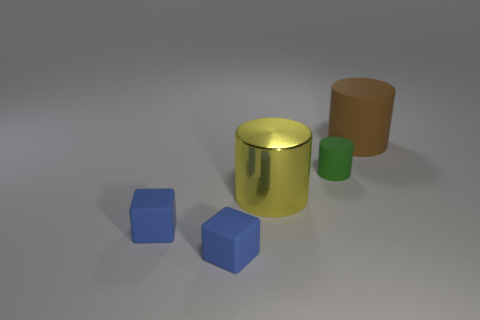What shape is the large object in front of the object behind the tiny cylinder?
Your answer should be very brief. Cylinder. There is a tiny cylinder that is made of the same material as the brown thing; what is its color?
Provide a short and direct response. Green. Is there any other thing that has the same size as the green matte cylinder?
Ensure brevity in your answer.  Yes. There is a big cylinder on the right side of the big yellow shiny thing; does it have the same color as the shiny cylinder that is in front of the green thing?
Your answer should be very brief. No. Are there more large matte cylinders that are to the left of the big yellow shiny cylinder than large rubber objects right of the brown cylinder?
Provide a short and direct response. No. What color is the other matte thing that is the same shape as the large brown object?
Offer a very short reply. Green. Are there any other things that are the same shape as the big rubber object?
Your response must be concise. Yes. There is a green object; is its shape the same as the big brown object to the right of the big metallic cylinder?
Your response must be concise. Yes. How many other things are there of the same material as the yellow object?
Provide a succinct answer. 0. There is a large rubber object; does it have the same color as the small thing that is to the right of the large yellow shiny cylinder?
Ensure brevity in your answer.  No. 